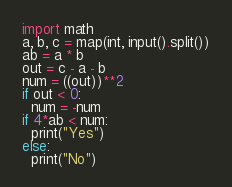<code> <loc_0><loc_0><loc_500><loc_500><_Python_>import math
a, b, c = map(int, input().split())
ab = a * b
out = c - a - b
num = ((out))**2
if out < 0:
  num = -num 
if 4*ab < num:
  print("Yes")
else:
  print("No")





</code> 